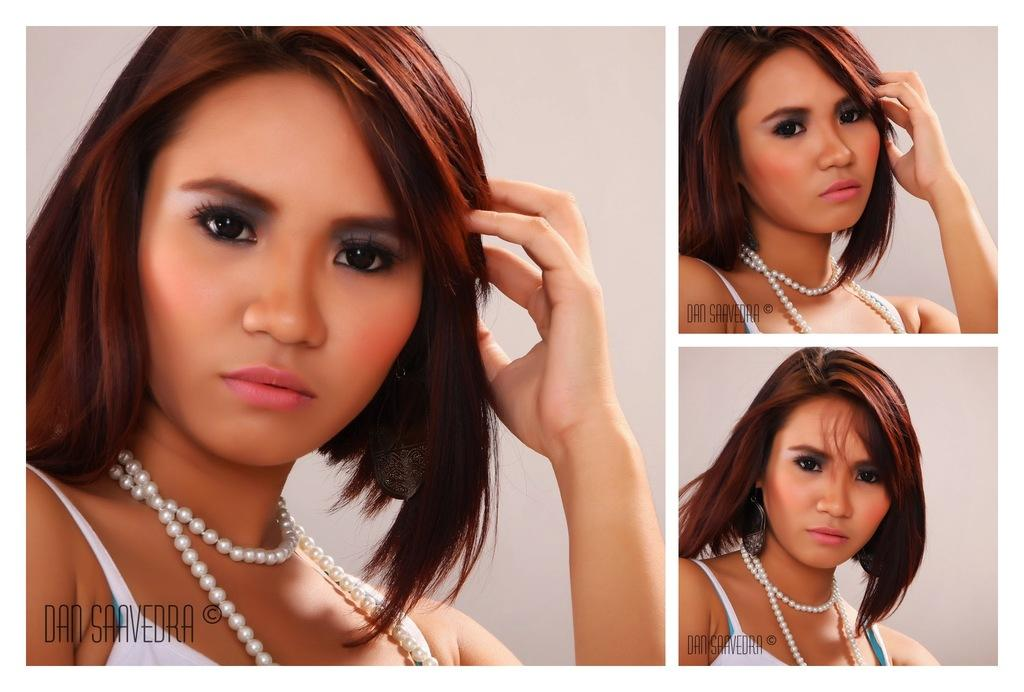What is the format of the image? The image is a collage of different pictures. Can you describe any people or characters in the pictures? There is a woman in the pictures. Is there any text present in the image? Yes, there is text in the bottom left of all the pictures. What type of reward is the woman receiving in the image? There is no indication in the image that the woman is receiving a reward, as the facts provided do not mention any such activity. 